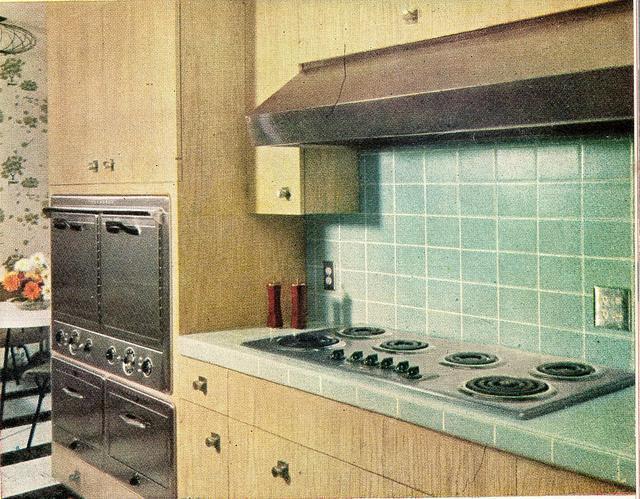How many burners are on this stove-top?
Give a very brief answer. 6. How many ovens are there?
Give a very brief answer. 2. 